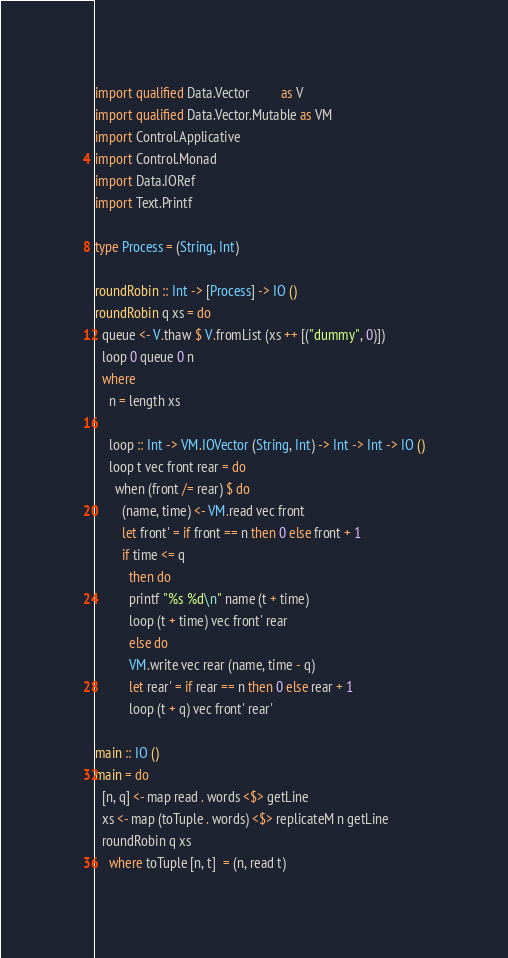<code> <loc_0><loc_0><loc_500><loc_500><_Haskell_>import qualified Data.Vector         as V
import qualified Data.Vector.Mutable as VM
import Control.Applicative
import Control.Monad
import Data.IORef
import Text.Printf

type Process = (String, Int)

roundRobin :: Int -> [Process] -> IO ()
roundRobin q xs = do
  queue <- V.thaw $ V.fromList (xs ++ [("dummy", 0)])
  loop 0 queue 0 n
  where
    n = length xs
    
    loop :: Int -> VM.IOVector (String, Int) -> Int -> Int -> IO ()
    loop t vec front rear = do
      when (front /= rear) $ do
        (name, time) <- VM.read vec front
        let front' = if front == n then 0 else front + 1
        if time <= q
          then do
          printf "%s %d\n" name (t + time)
          loop (t + time) vec front' rear
          else do
          VM.write vec rear (name, time - q)
          let rear' = if rear == n then 0 else rear + 1
          loop (t + q) vec front' rear'

main :: IO ()
main = do
  [n, q] <- map read . words <$> getLine
  xs <- map (toTuple . words) <$> replicateM n getLine
  roundRobin q xs
    where toTuple [n, t]  = (n, read t)

</code> 